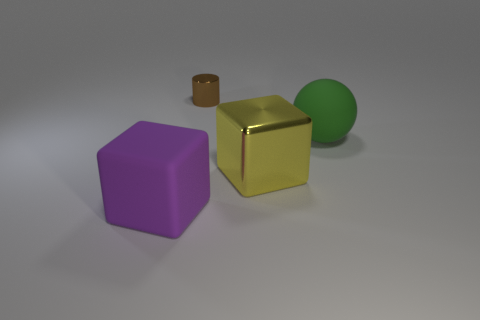Add 2 large spheres. How many objects exist? 6 Add 3 tiny shiny things. How many tiny shiny things are left? 4 Add 1 brown metallic cylinders. How many brown metallic cylinders exist? 2 Subtract all yellow blocks. How many blocks are left? 1 Subtract 0 brown cubes. How many objects are left? 4 Subtract all spheres. How many objects are left? 3 Subtract 2 blocks. How many blocks are left? 0 Subtract all cyan cubes. Subtract all blue balls. How many cubes are left? 2 Subtract all purple balls. How many yellow blocks are left? 1 Subtract all big blue matte balls. Subtract all large spheres. How many objects are left? 3 